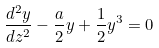Convert formula to latex. <formula><loc_0><loc_0><loc_500><loc_500>\frac { d ^ { 2 } y } { d z ^ { 2 } } - \frac { a } { 2 } y + \frac { 1 } { 2 } y ^ { 3 } = 0</formula> 